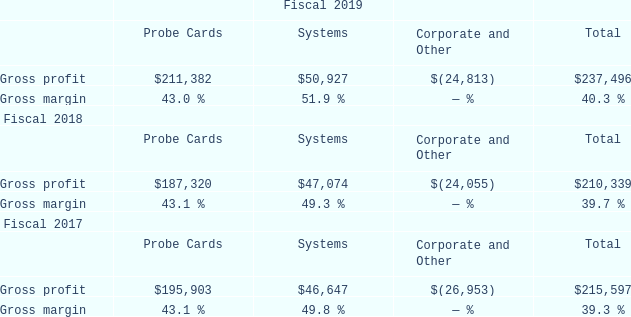Cost of Revenues and Gross Margins
Cost of revenues consists primarily of manufacturing materials, payroll, shipping and handling costs, manufacturing-related overhead and amortization of certain intangible assets. Our manufacturing operations rely on a limited number of suppliers to provide key components and materials for our products, some of which are a sole source. We order materials and supplies based on backlog and forecasted customer orders.
Tooling and setup costs related to changing manufacturing lots at our suppliers are also included in the cost of revenues. We expense all warranty costs, inventory provisions and amortization of certain intangible assets as cost of revenues. Gross profit and gross margin by segment were as follows (dollars in thousands):
Probe Cards Gross profit in the Probe Cards segment increased in fiscal 2019 compared to fiscal 2018 primarily due to increased sales, offset by higher variable costs and by less favorable product mix.
Systems Gross profit and gross margin in the Systems segment increased in fiscal 2019 compared to fiscal 2018 due to increased sales.
Corporate and Other Corporate and Other includes unallocated expenses relating to amortization of intangible assets, share-based compensation, restructuring charges, net, and acquisition-related costs, including charges related to inventory stepped up to fair value and other costs, which are not used in evaluating the results of, or in allocating resources to, our reportable segments.
Overall Gross profit and gross margin fluctuate with revenue levels, product mix, selling prices, factory loading and material costs. For fiscal 2019 compared to fiscal 2018, gross profit increased due to increased sales while gross margins remained relatively consistent with fluctuations in product mix.
Stock-based compensation expense included in gross profit for fiscal 2019 and 2018 was $4.1 million and $3.5 million, respectively.
What led to increase in Gross profit and gross margin in the Systems segment in fiscal 2019 compared to fiscal 2018? Gross profit and gross margin in the systems segment increased in fiscal 2019 compared to fiscal 2018 due to increased sales. What is the increase/ (decrease) in Gross profit of Probe Cards from fiscal 2019 to 2018?
Answer scale should be: thousand. 211,382-187,320
Answer: 24062. What is the increase/ (decrease) in Gross profit of Systems from fiscal 2019 to 2018?
Answer scale should be: thousand. 50,927-47,074
Answer: 3853. For which revenue segment was Gross margin under 50.0% in 2019? Locate and analyze gross margin in row 4
answer: probe cards, corporate and other. What does cost of revenues include? Onsists primarily of manufacturing materials, payroll, shipping and handling costs, manufacturing-related overhead and amortization of certain intangible assets. What was the Gross Profit in 2019 for Probe Cards and Systems?
Answer scale should be: percent. 43.0, 51.9. 